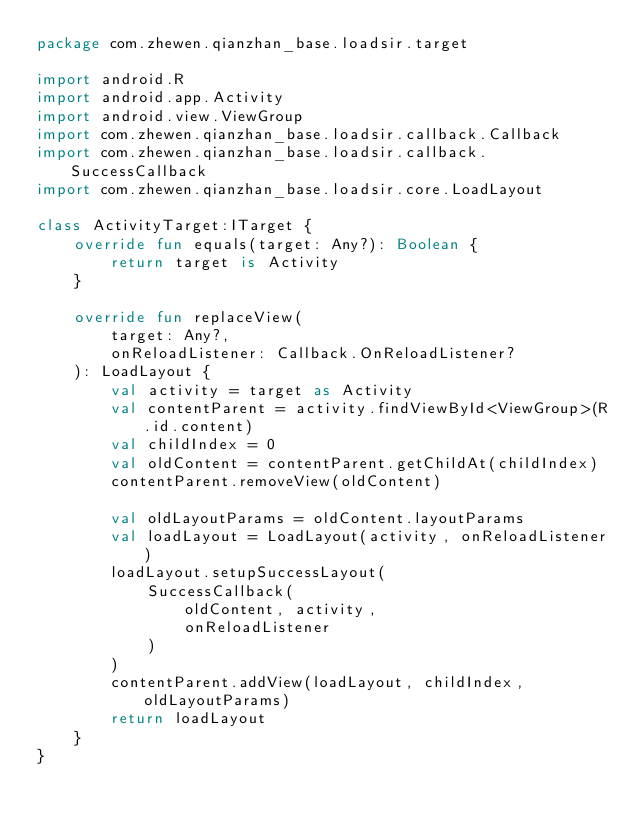<code> <loc_0><loc_0><loc_500><loc_500><_Kotlin_>package com.zhewen.qianzhan_base.loadsir.target

import android.R
import android.app.Activity
import android.view.ViewGroup
import com.zhewen.qianzhan_base.loadsir.callback.Callback
import com.zhewen.qianzhan_base.loadsir.callback.SuccessCallback
import com.zhewen.qianzhan_base.loadsir.core.LoadLayout

class ActivityTarget:ITarget {
    override fun equals(target: Any?): Boolean {
        return target is Activity
    }

    override fun replaceView(
        target: Any?,
        onReloadListener: Callback.OnReloadListener?
    ): LoadLayout {
        val activity = target as Activity
        val contentParent = activity.findViewById<ViewGroup>(R.id.content)
        val childIndex = 0
        val oldContent = contentParent.getChildAt(childIndex)
        contentParent.removeView(oldContent)

        val oldLayoutParams = oldContent.layoutParams
        val loadLayout = LoadLayout(activity, onReloadListener)
        loadLayout.setupSuccessLayout(
            SuccessCallback(
                oldContent, activity,
                onReloadListener
            )
        )
        contentParent.addView(loadLayout, childIndex, oldLayoutParams)
        return loadLayout
    }
}</code> 